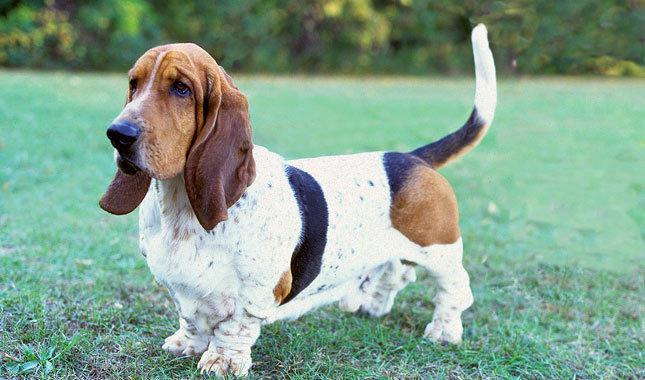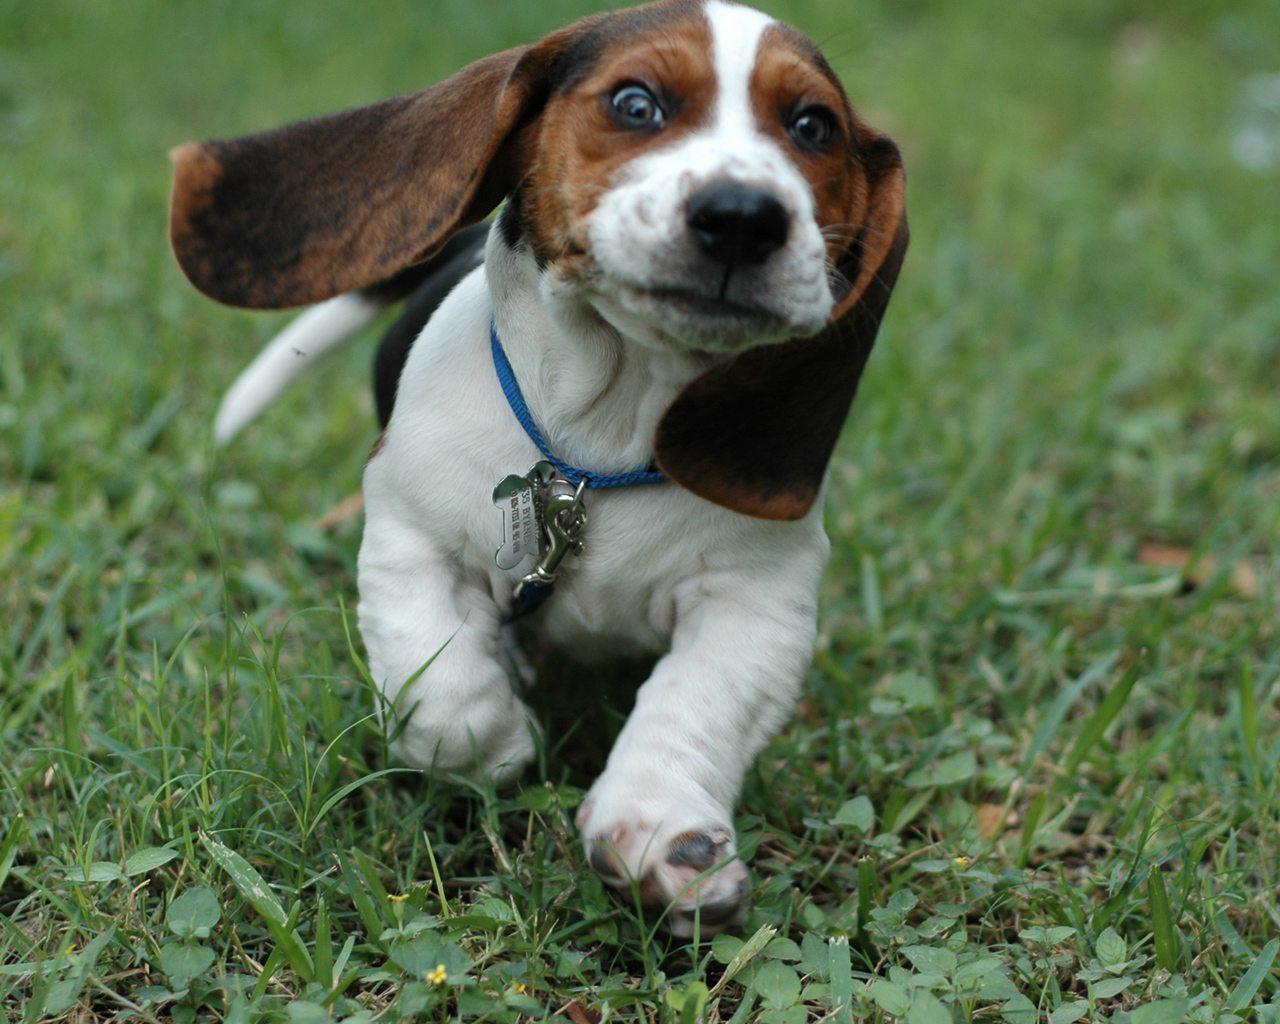The first image is the image on the left, the second image is the image on the right. Examine the images to the left and right. Is the description "The dog in the image on the right is running toward the camera." accurate? Answer yes or no. Yes. 